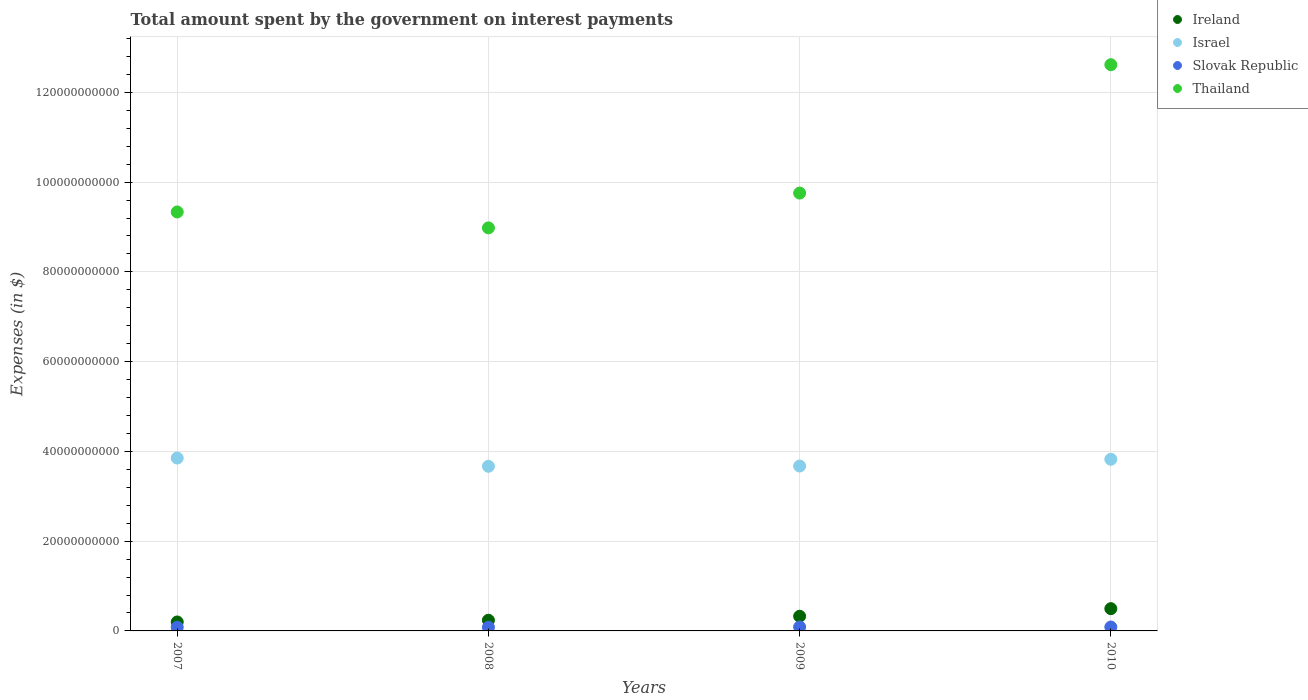How many different coloured dotlines are there?
Your response must be concise. 4. Is the number of dotlines equal to the number of legend labels?
Provide a short and direct response. Yes. What is the amount spent on interest payments by the government in Thailand in 2008?
Ensure brevity in your answer.  8.98e+1. Across all years, what is the maximum amount spent on interest payments by the government in Slovak Republic?
Ensure brevity in your answer.  8.80e+08. Across all years, what is the minimum amount spent on interest payments by the government in Israel?
Keep it short and to the point. 3.67e+1. What is the total amount spent on interest payments by the government in Israel in the graph?
Your answer should be very brief. 1.50e+11. What is the difference between the amount spent on interest payments by the government in Slovak Republic in 2007 and that in 2009?
Offer a very short reply. -6.61e+07. What is the difference between the amount spent on interest payments by the government in Ireland in 2008 and the amount spent on interest payments by the government in Slovak Republic in 2009?
Ensure brevity in your answer.  1.50e+09. What is the average amount spent on interest payments by the government in Slovak Republic per year?
Keep it short and to the point. 8.46e+08. In the year 2008, what is the difference between the amount spent on interest payments by the government in Ireland and amount spent on interest payments by the government in Thailand?
Offer a terse response. -8.74e+1. In how many years, is the amount spent on interest payments by the government in Slovak Republic greater than 68000000000 $?
Your response must be concise. 0. What is the ratio of the amount spent on interest payments by the government in Israel in 2008 to that in 2009?
Provide a short and direct response. 1. Is the amount spent on interest payments by the government in Israel in 2007 less than that in 2010?
Provide a succinct answer. No. Is the difference between the amount spent on interest payments by the government in Ireland in 2007 and 2008 greater than the difference between the amount spent on interest payments by the government in Thailand in 2007 and 2008?
Offer a terse response. No. What is the difference between the highest and the second highest amount spent on interest payments by the government in Israel?
Your answer should be very brief. 2.76e+08. What is the difference between the highest and the lowest amount spent on interest payments by the government in Thailand?
Provide a short and direct response. 3.64e+1. Is the sum of the amount spent on interest payments by the government in Israel in 2007 and 2010 greater than the maximum amount spent on interest payments by the government in Thailand across all years?
Provide a short and direct response. No. Is it the case that in every year, the sum of the amount spent on interest payments by the government in Thailand and amount spent on interest payments by the government in Ireland  is greater than the sum of amount spent on interest payments by the government in Israel and amount spent on interest payments by the government in Slovak Republic?
Provide a succinct answer. No. Does the amount spent on interest payments by the government in Thailand monotonically increase over the years?
Your response must be concise. No. How many dotlines are there?
Keep it short and to the point. 4. Where does the legend appear in the graph?
Your answer should be very brief. Top right. What is the title of the graph?
Ensure brevity in your answer.  Total amount spent by the government on interest payments. What is the label or title of the Y-axis?
Offer a very short reply. Expenses (in $). What is the Expenses (in $) in Ireland in 2007?
Your answer should be compact. 1.99e+09. What is the Expenses (in $) of Israel in 2007?
Ensure brevity in your answer.  3.85e+1. What is the Expenses (in $) of Slovak Republic in 2007?
Provide a succinct answer. 8.14e+08. What is the Expenses (in $) of Thailand in 2007?
Your response must be concise. 9.33e+1. What is the Expenses (in $) in Ireland in 2008?
Offer a terse response. 2.38e+09. What is the Expenses (in $) in Israel in 2008?
Your answer should be compact. 3.67e+1. What is the Expenses (in $) in Slovak Republic in 2008?
Your answer should be very brief. 8.18e+08. What is the Expenses (in $) in Thailand in 2008?
Your answer should be very brief. 8.98e+1. What is the Expenses (in $) of Ireland in 2009?
Your answer should be very brief. 3.27e+09. What is the Expenses (in $) of Israel in 2009?
Your response must be concise. 3.67e+1. What is the Expenses (in $) of Slovak Republic in 2009?
Provide a succinct answer. 8.80e+08. What is the Expenses (in $) in Thailand in 2009?
Give a very brief answer. 9.76e+1. What is the Expenses (in $) of Ireland in 2010?
Your answer should be very brief. 4.96e+09. What is the Expenses (in $) of Israel in 2010?
Ensure brevity in your answer.  3.82e+1. What is the Expenses (in $) of Slovak Republic in 2010?
Make the answer very short. 8.71e+08. What is the Expenses (in $) of Thailand in 2010?
Your answer should be very brief. 1.26e+11. Across all years, what is the maximum Expenses (in $) in Ireland?
Offer a very short reply. 4.96e+09. Across all years, what is the maximum Expenses (in $) in Israel?
Keep it short and to the point. 3.85e+1. Across all years, what is the maximum Expenses (in $) in Slovak Republic?
Your response must be concise. 8.80e+08. Across all years, what is the maximum Expenses (in $) of Thailand?
Your answer should be very brief. 1.26e+11. Across all years, what is the minimum Expenses (in $) in Ireland?
Give a very brief answer. 1.99e+09. Across all years, what is the minimum Expenses (in $) in Israel?
Make the answer very short. 3.67e+1. Across all years, what is the minimum Expenses (in $) in Slovak Republic?
Ensure brevity in your answer.  8.14e+08. Across all years, what is the minimum Expenses (in $) of Thailand?
Provide a succinct answer. 8.98e+1. What is the total Expenses (in $) in Ireland in the graph?
Give a very brief answer. 1.26e+1. What is the total Expenses (in $) in Israel in the graph?
Your answer should be very brief. 1.50e+11. What is the total Expenses (in $) in Slovak Republic in the graph?
Provide a succinct answer. 3.38e+09. What is the total Expenses (in $) in Thailand in the graph?
Make the answer very short. 4.07e+11. What is the difference between the Expenses (in $) of Ireland in 2007 and that in 2008?
Your answer should be compact. -3.86e+08. What is the difference between the Expenses (in $) of Israel in 2007 and that in 2008?
Offer a very short reply. 1.84e+09. What is the difference between the Expenses (in $) of Slovak Republic in 2007 and that in 2008?
Provide a short and direct response. -4.01e+06. What is the difference between the Expenses (in $) in Thailand in 2007 and that in 2008?
Keep it short and to the point. 3.55e+09. What is the difference between the Expenses (in $) in Ireland in 2007 and that in 2009?
Ensure brevity in your answer.  -1.27e+09. What is the difference between the Expenses (in $) of Israel in 2007 and that in 2009?
Ensure brevity in your answer.  1.78e+09. What is the difference between the Expenses (in $) in Slovak Republic in 2007 and that in 2009?
Your response must be concise. -6.61e+07. What is the difference between the Expenses (in $) in Thailand in 2007 and that in 2009?
Offer a terse response. -4.21e+09. What is the difference between the Expenses (in $) of Ireland in 2007 and that in 2010?
Your answer should be very brief. -2.97e+09. What is the difference between the Expenses (in $) in Israel in 2007 and that in 2010?
Keep it short and to the point. 2.76e+08. What is the difference between the Expenses (in $) in Slovak Republic in 2007 and that in 2010?
Provide a short and direct response. -5.68e+07. What is the difference between the Expenses (in $) of Thailand in 2007 and that in 2010?
Give a very brief answer. -3.28e+1. What is the difference between the Expenses (in $) of Ireland in 2008 and that in 2009?
Offer a very short reply. -8.87e+08. What is the difference between the Expenses (in $) of Israel in 2008 and that in 2009?
Make the answer very short. -5.49e+07. What is the difference between the Expenses (in $) of Slovak Republic in 2008 and that in 2009?
Provide a short and direct response. -6.21e+07. What is the difference between the Expenses (in $) of Thailand in 2008 and that in 2009?
Ensure brevity in your answer.  -7.75e+09. What is the difference between the Expenses (in $) of Ireland in 2008 and that in 2010?
Your answer should be very brief. -2.58e+09. What is the difference between the Expenses (in $) of Israel in 2008 and that in 2010?
Your answer should be very brief. -1.56e+09. What is the difference between the Expenses (in $) of Slovak Republic in 2008 and that in 2010?
Keep it short and to the point. -5.28e+07. What is the difference between the Expenses (in $) of Thailand in 2008 and that in 2010?
Your answer should be very brief. -3.64e+1. What is the difference between the Expenses (in $) in Ireland in 2009 and that in 2010?
Offer a very short reply. -1.69e+09. What is the difference between the Expenses (in $) in Israel in 2009 and that in 2010?
Your answer should be compact. -1.51e+09. What is the difference between the Expenses (in $) of Slovak Republic in 2009 and that in 2010?
Your answer should be very brief. 9.30e+06. What is the difference between the Expenses (in $) in Thailand in 2009 and that in 2010?
Your answer should be compact. -2.86e+1. What is the difference between the Expenses (in $) in Ireland in 2007 and the Expenses (in $) in Israel in 2008?
Give a very brief answer. -3.47e+1. What is the difference between the Expenses (in $) in Ireland in 2007 and the Expenses (in $) in Slovak Republic in 2008?
Offer a very short reply. 1.18e+09. What is the difference between the Expenses (in $) of Ireland in 2007 and the Expenses (in $) of Thailand in 2008?
Your response must be concise. -8.78e+1. What is the difference between the Expenses (in $) in Israel in 2007 and the Expenses (in $) in Slovak Republic in 2008?
Your answer should be very brief. 3.77e+1. What is the difference between the Expenses (in $) of Israel in 2007 and the Expenses (in $) of Thailand in 2008?
Provide a succinct answer. -5.13e+1. What is the difference between the Expenses (in $) of Slovak Republic in 2007 and the Expenses (in $) of Thailand in 2008?
Offer a very short reply. -8.90e+1. What is the difference between the Expenses (in $) of Ireland in 2007 and the Expenses (in $) of Israel in 2009?
Provide a succinct answer. -3.47e+1. What is the difference between the Expenses (in $) of Ireland in 2007 and the Expenses (in $) of Slovak Republic in 2009?
Provide a succinct answer. 1.11e+09. What is the difference between the Expenses (in $) of Ireland in 2007 and the Expenses (in $) of Thailand in 2009?
Offer a very short reply. -9.56e+1. What is the difference between the Expenses (in $) in Israel in 2007 and the Expenses (in $) in Slovak Republic in 2009?
Offer a terse response. 3.76e+1. What is the difference between the Expenses (in $) in Israel in 2007 and the Expenses (in $) in Thailand in 2009?
Provide a short and direct response. -5.90e+1. What is the difference between the Expenses (in $) in Slovak Republic in 2007 and the Expenses (in $) in Thailand in 2009?
Your answer should be very brief. -9.67e+1. What is the difference between the Expenses (in $) in Ireland in 2007 and the Expenses (in $) in Israel in 2010?
Provide a short and direct response. -3.62e+1. What is the difference between the Expenses (in $) of Ireland in 2007 and the Expenses (in $) of Slovak Republic in 2010?
Keep it short and to the point. 1.12e+09. What is the difference between the Expenses (in $) in Ireland in 2007 and the Expenses (in $) in Thailand in 2010?
Keep it short and to the point. -1.24e+11. What is the difference between the Expenses (in $) of Israel in 2007 and the Expenses (in $) of Slovak Republic in 2010?
Offer a very short reply. 3.76e+1. What is the difference between the Expenses (in $) in Israel in 2007 and the Expenses (in $) in Thailand in 2010?
Your response must be concise. -8.76e+1. What is the difference between the Expenses (in $) in Slovak Republic in 2007 and the Expenses (in $) in Thailand in 2010?
Keep it short and to the point. -1.25e+11. What is the difference between the Expenses (in $) of Ireland in 2008 and the Expenses (in $) of Israel in 2009?
Provide a short and direct response. -3.44e+1. What is the difference between the Expenses (in $) of Ireland in 2008 and the Expenses (in $) of Slovak Republic in 2009?
Provide a short and direct response. 1.50e+09. What is the difference between the Expenses (in $) in Ireland in 2008 and the Expenses (in $) in Thailand in 2009?
Ensure brevity in your answer.  -9.52e+1. What is the difference between the Expenses (in $) of Israel in 2008 and the Expenses (in $) of Slovak Republic in 2009?
Ensure brevity in your answer.  3.58e+1. What is the difference between the Expenses (in $) of Israel in 2008 and the Expenses (in $) of Thailand in 2009?
Provide a short and direct response. -6.09e+1. What is the difference between the Expenses (in $) of Slovak Republic in 2008 and the Expenses (in $) of Thailand in 2009?
Make the answer very short. -9.67e+1. What is the difference between the Expenses (in $) of Ireland in 2008 and the Expenses (in $) of Israel in 2010?
Keep it short and to the point. -3.59e+1. What is the difference between the Expenses (in $) in Ireland in 2008 and the Expenses (in $) in Slovak Republic in 2010?
Give a very brief answer. 1.51e+09. What is the difference between the Expenses (in $) in Ireland in 2008 and the Expenses (in $) in Thailand in 2010?
Offer a terse response. -1.24e+11. What is the difference between the Expenses (in $) of Israel in 2008 and the Expenses (in $) of Slovak Republic in 2010?
Offer a very short reply. 3.58e+1. What is the difference between the Expenses (in $) in Israel in 2008 and the Expenses (in $) in Thailand in 2010?
Your answer should be compact. -8.95e+1. What is the difference between the Expenses (in $) in Slovak Republic in 2008 and the Expenses (in $) in Thailand in 2010?
Keep it short and to the point. -1.25e+11. What is the difference between the Expenses (in $) of Ireland in 2009 and the Expenses (in $) of Israel in 2010?
Your response must be concise. -3.50e+1. What is the difference between the Expenses (in $) in Ireland in 2009 and the Expenses (in $) in Slovak Republic in 2010?
Offer a very short reply. 2.40e+09. What is the difference between the Expenses (in $) of Ireland in 2009 and the Expenses (in $) of Thailand in 2010?
Offer a very short reply. -1.23e+11. What is the difference between the Expenses (in $) in Israel in 2009 and the Expenses (in $) in Slovak Republic in 2010?
Your answer should be compact. 3.59e+1. What is the difference between the Expenses (in $) in Israel in 2009 and the Expenses (in $) in Thailand in 2010?
Ensure brevity in your answer.  -8.94e+1. What is the difference between the Expenses (in $) of Slovak Republic in 2009 and the Expenses (in $) of Thailand in 2010?
Provide a short and direct response. -1.25e+11. What is the average Expenses (in $) of Ireland per year?
Your answer should be compact. 3.15e+09. What is the average Expenses (in $) in Israel per year?
Give a very brief answer. 3.75e+1. What is the average Expenses (in $) of Slovak Republic per year?
Your response must be concise. 8.46e+08. What is the average Expenses (in $) of Thailand per year?
Keep it short and to the point. 1.02e+11. In the year 2007, what is the difference between the Expenses (in $) of Ireland and Expenses (in $) of Israel?
Your answer should be compact. -3.65e+1. In the year 2007, what is the difference between the Expenses (in $) in Ireland and Expenses (in $) in Slovak Republic?
Your answer should be very brief. 1.18e+09. In the year 2007, what is the difference between the Expenses (in $) in Ireland and Expenses (in $) in Thailand?
Your response must be concise. -9.14e+1. In the year 2007, what is the difference between the Expenses (in $) in Israel and Expenses (in $) in Slovak Republic?
Your answer should be compact. 3.77e+1. In the year 2007, what is the difference between the Expenses (in $) of Israel and Expenses (in $) of Thailand?
Provide a short and direct response. -5.48e+1. In the year 2007, what is the difference between the Expenses (in $) of Slovak Republic and Expenses (in $) of Thailand?
Offer a very short reply. -9.25e+1. In the year 2008, what is the difference between the Expenses (in $) of Ireland and Expenses (in $) of Israel?
Offer a terse response. -3.43e+1. In the year 2008, what is the difference between the Expenses (in $) in Ireland and Expenses (in $) in Slovak Republic?
Ensure brevity in your answer.  1.56e+09. In the year 2008, what is the difference between the Expenses (in $) in Ireland and Expenses (in $) in Thailand?
Keep it short and to the point. -8.74e+1. In the year 2008, what is the difference between the Expenses (in $) in Israel and Expenses (in $) in Slovak Republic?
Provide a succinct answer. 3.59e+1. In the year 2008, what is the difference between the Expenses (in $) of Israel and Expenses (in $) of Thailand?
Your answer should be compact. -5.31e+1. In the year 2008, what is the difference between the Expenses (in $) in Slovak Republic and Expenses (in $) in Thailand?
Ensure brevity in your answer.  -8.90e+1. In the year 2009, what is the difference between the Expenses (in $) of Ireland and Expenses (in $) of Israel?
Your response must be concise. -3.35e+1. In the year 2009, what is the difference between the Expenses (in $) of Ireland and Expenses (in $) of Slovak Republic?
Offer a terse response. 2.39e+09. In the year 2009, what is the difference between the Expenses (in $) of Ireland and Expenses (in $) of Thailand?
Your response must be concise. -9.43e+1. In the year 2009, what is the difference between the Expenses (in $) in Israel and Expenses (in $) in Slovak Republic?
Give a very brief answer. 3.59e+1. In the year 2009, what is the difference between the Expenses (in $) in Israel and Expenses (in $) in Thailand?
Give a very brief answer. -6.08e+1. In the year 2009, what is the difference between the Expenses (in $) in Slovak Republic and Expenses (in $) in Thailand?
Offer a terse response. -9.67e+1. In the year 2010, what is the difference between the Expenses (in $) in Ireland and Expenses (in $) in Israel?
Give a very brief answer. -3.33e+1. In the year 2010, what is the difference between the Expenses (in $) of Ireland and Expenses (in $) of Slovak Republic?
Your answer should be very brief. 4.09e+09. In the year 2010, what is the difference between the Expenses (in $) in Ireland and Expenses (in $) in Thailand?
Make the answer very short. -1.21e+11. In the year 2010, what is the difference between the Expenses (in $) of Israel and Expenses (in $) of Slovak Republic?
Your answer should be very brief. 3.74e+1. In the year 2010, what is the difference between the Expenses (in $) in Israel and Expenses (in $) in Thailand?
Provide a succinct answer. -8.79e+1. In the year 2010, what is the difference between the Expenses (in $) of Slovak Republic and Expenses (in $) of Thailand?
Keep it short and to the point. -1.25e+11. What is the ratio of the Expenses (in $) of Ireland in 2007 to that in 2008?
Give a very brief answer. 0.84. What is the ratio of the Expenses (in $) in Israel in 2007 to that in 2008?
Make the answer very short. 1.05. What is the ratio of the Expenses (in $) of Thailand in 2007 to that in 2008?
Offer a terse response. 1.04. What is the ratio of the Expenses (in $) in Ireland in 2007 to that in 2009?
Your response must be concise. 0.61. What is the ratio of the Expenses (in $) in Israel in 2007 to that in 2009?
Ensure brevity in your answer.  1.05. What is the ratio of the Expenses (in $) of Slovak Republic in 2007 to that in 2009?
Offer a very short reply. 0.92. What is the ratio of the Expenses (in $) in Thailand in 2007 to that in 2009?
Offer a terse response. 0.96. What is the ratio of the Expenses (in $) in Ireland in 2007 to that in 2010?
Provide a short and direct response. 0.4. What is the ratio of the Expenses (in $) in Israel in 2007 to that in 2010?
Your answer should be very brief. 1.01. What is the ratio of the Expenses (in $) of Slovak Republic in 2007 to that in 2010?
Keep it short and to the point. 0.93. What is the ratio of the Expenses (in $) in Thailand in 2007 to that in 2010?
Your response must be concise. 0.74. What is the ratio of the Expenses (in $) of Ireland in 2008 to that in 2009?
Offer a very short reply. 0.73. What is the ratio of the Expenses (in $) of Israel in 2008 to that in 2009?
Offer a very short reply. 1. What is the ratio of the Expenses (in $) in Slovak Republic in 2008 to that in 2009?
Give a very brief answer. 0.93. What is the ratio of the Expenses (in $) in Thailand in 2008 to that in 2009?
Keep it short and to the point. 0.92. What is the ratio of the Expenses (in $) in Ireland in 2008 to that in 2010?
Provide a succinct answer. 0.48. What is the ratio of the Expenses (in $) in Israel in 2008 to that in 2010?
Give a very brief answer. 0.96. What is the ratio of the Expenses (in $) of Slovak Republic in 2008 to that in 2010?
Make the answer very short. 0.94. What is the ratio of the Expenses (in $) of Thailand in 2008 to that in 2010?
Your answer should be compact. 0.71. What is the ratio of the Expenses (in $) in Ireland in 2009 to that in 2010?
Offer a terse response. 0.66. What is the ratio of the Expenses (in $) of Israel in 2009 to that in 2010?
Your answer should be compact. 0.96. What is the ratio of the Expenses (in $) of Slovak Republic in 2009 to that in 2010?
Your answer should be compact. 1.01. What is the ratio of the Expenses (in $) in Thailand in 2009 to that in 2010?
Make the answer very short. 0.77. What is the difference between the highest and the second highest Expenses (in $) of Ireland?
Offer a terse response. 1.69e+09. What is the difference between the highest and the second highest Expenses (in $) of Israel?
Provide a succinct answer. 2.76e+08. What is the difference between the highest and the second highest Expenses (in $) in Slovak Republic?
Your answer should be very brief. 9.30e+06. What is the difference between the highest and the second highest Expenses (in $) of Thailand?
Offer a terse response. 2.86e+1. What is the difference between the highest and the lowest Expenses (in $) of Ireland?
Your answer should be very brief. 2.97e+09. What is the difference between the highest and the lowest Expenses (in $) in Israel?
Your answer should be very brief. 1.84e+09. What is the difference between the highest and the lowest Expenses (in $) in Slovak Republic?
Your answer should be compact. 6.61e+07. What is the difference between the highest and the lowest Expenses (in $) of Thailand?
Provide a short and direct response. 3.64e+1. 